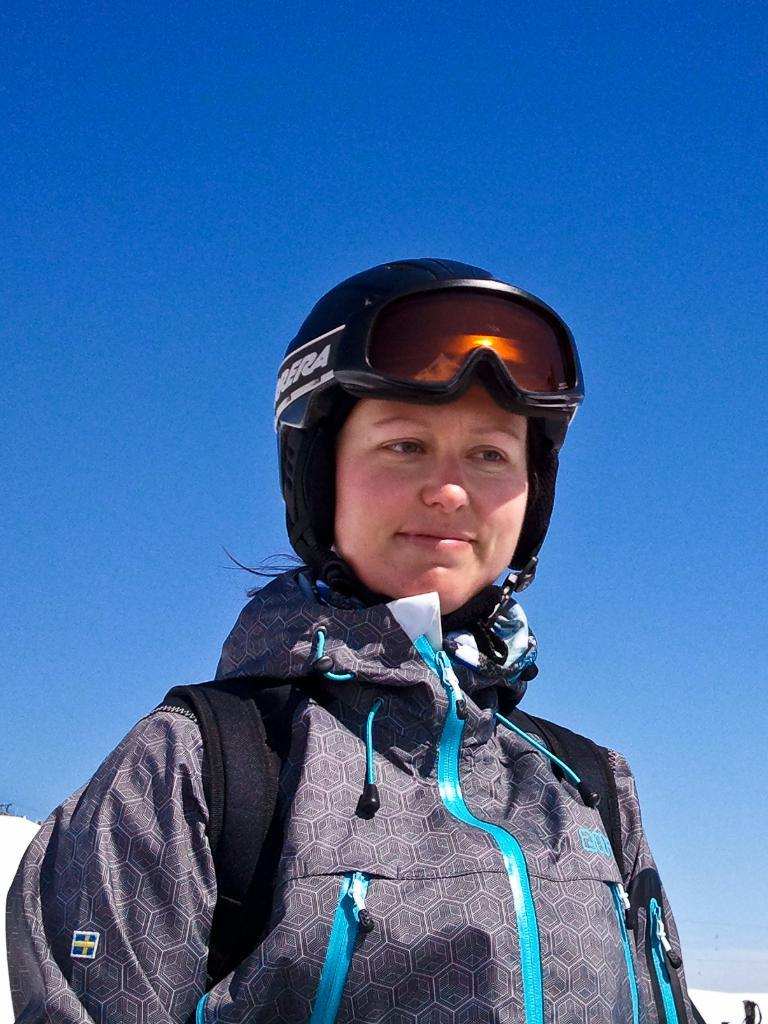Who is present in the image? There is a woman in the image. What is the woman wearing on her head? The woman is wearing a helmet. What else is the woman carrying in the image? The woman is wearing a bag. What type of cakes can be seen in the image? There are no cakes present in the image; it features a woman wearing a helmet and a bag. Is the woman moving or walking in the image? The image does not show the woman moving or walking; it only shows her standing still. 